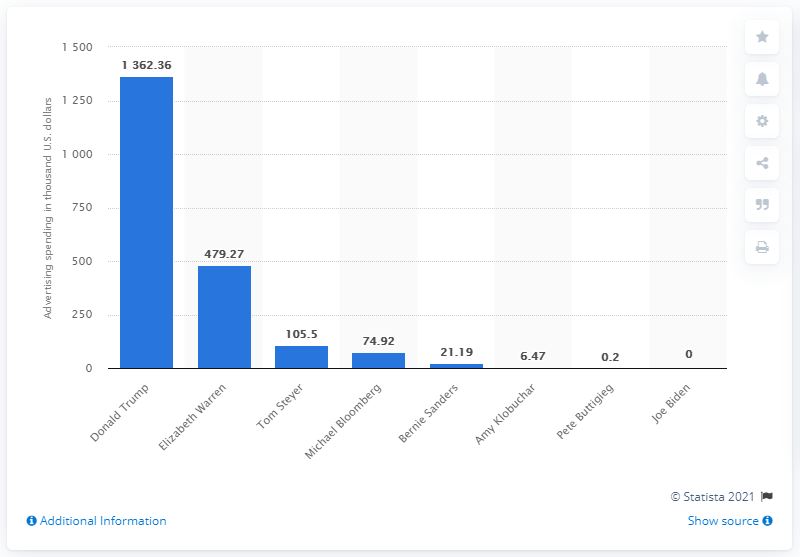Identify some key points in this picture. Elizabeth Warren spent the second largest amount of Facebook ads in the first half of 2020. 